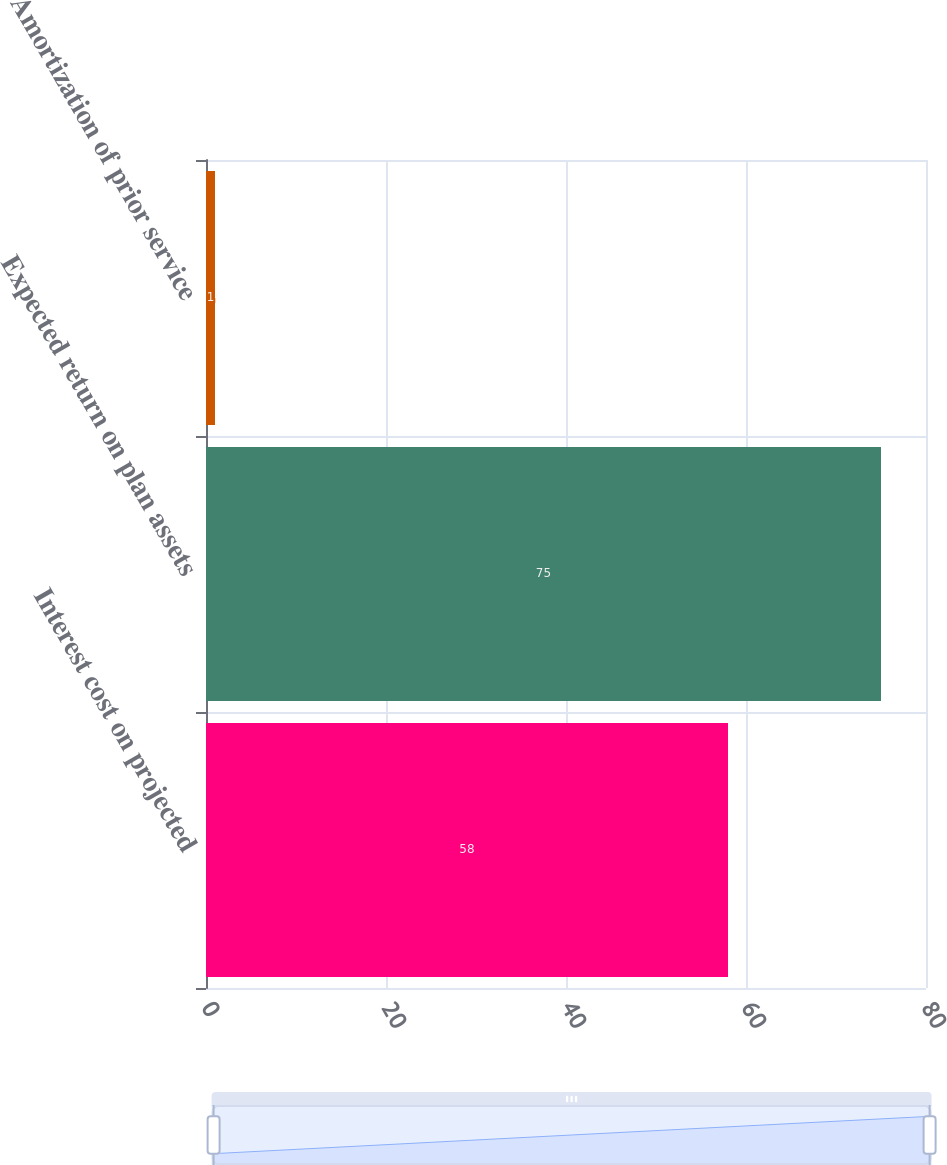Convert chart. <chart><loc_0><loc_0><loc_500><loc_500><bar_chart><fcel>Interest cost on projected<fcel>Expected return on plan assets<fcel>Amortization of prior service<nl><fcel>58<fcel>75<fcel>1<nl></chart> 